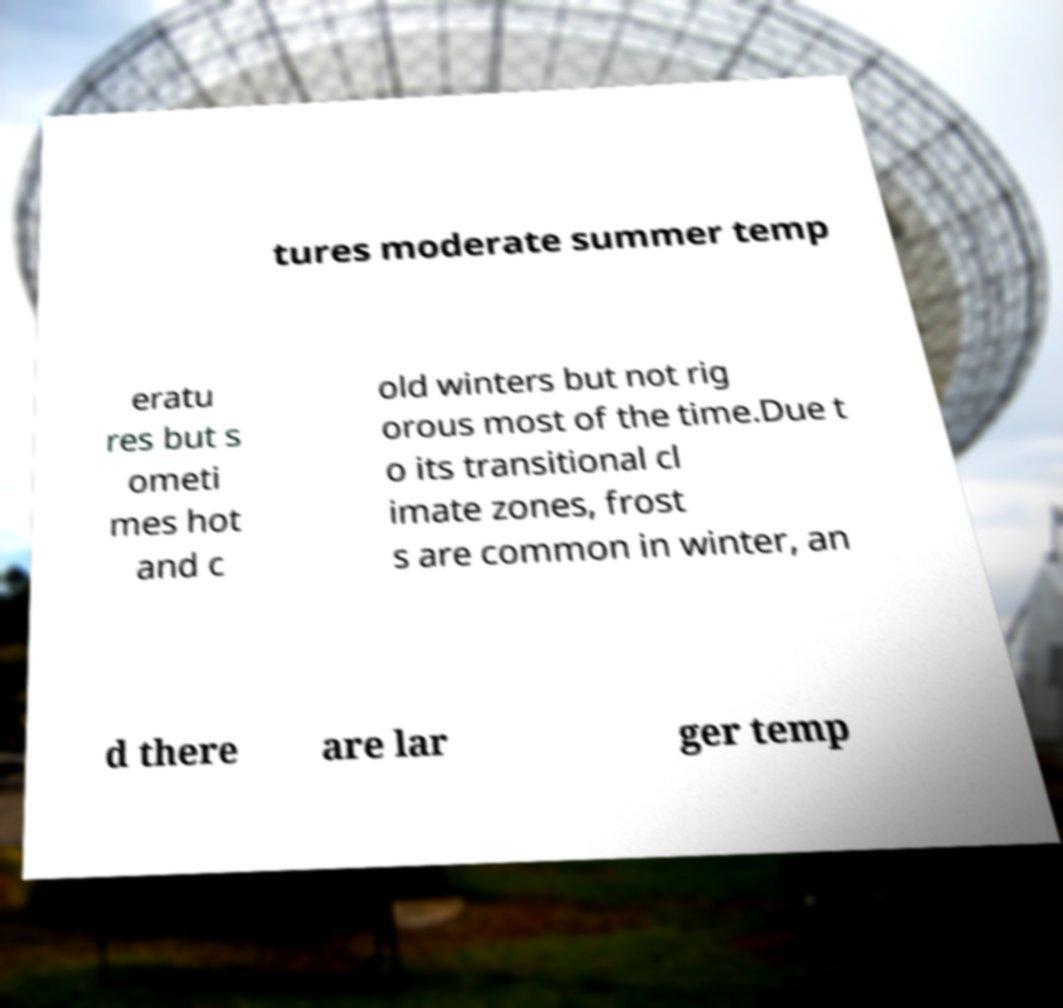For documentation purposes, I need the text within this image transcribed. Could you provide that? tures moderate summer temp eratu res but s ometi mes hot and c old winters but not rig orous most of the time.Due t o its transitional cl imate zones, frost s are common in winter, an d there are lar ger temp 